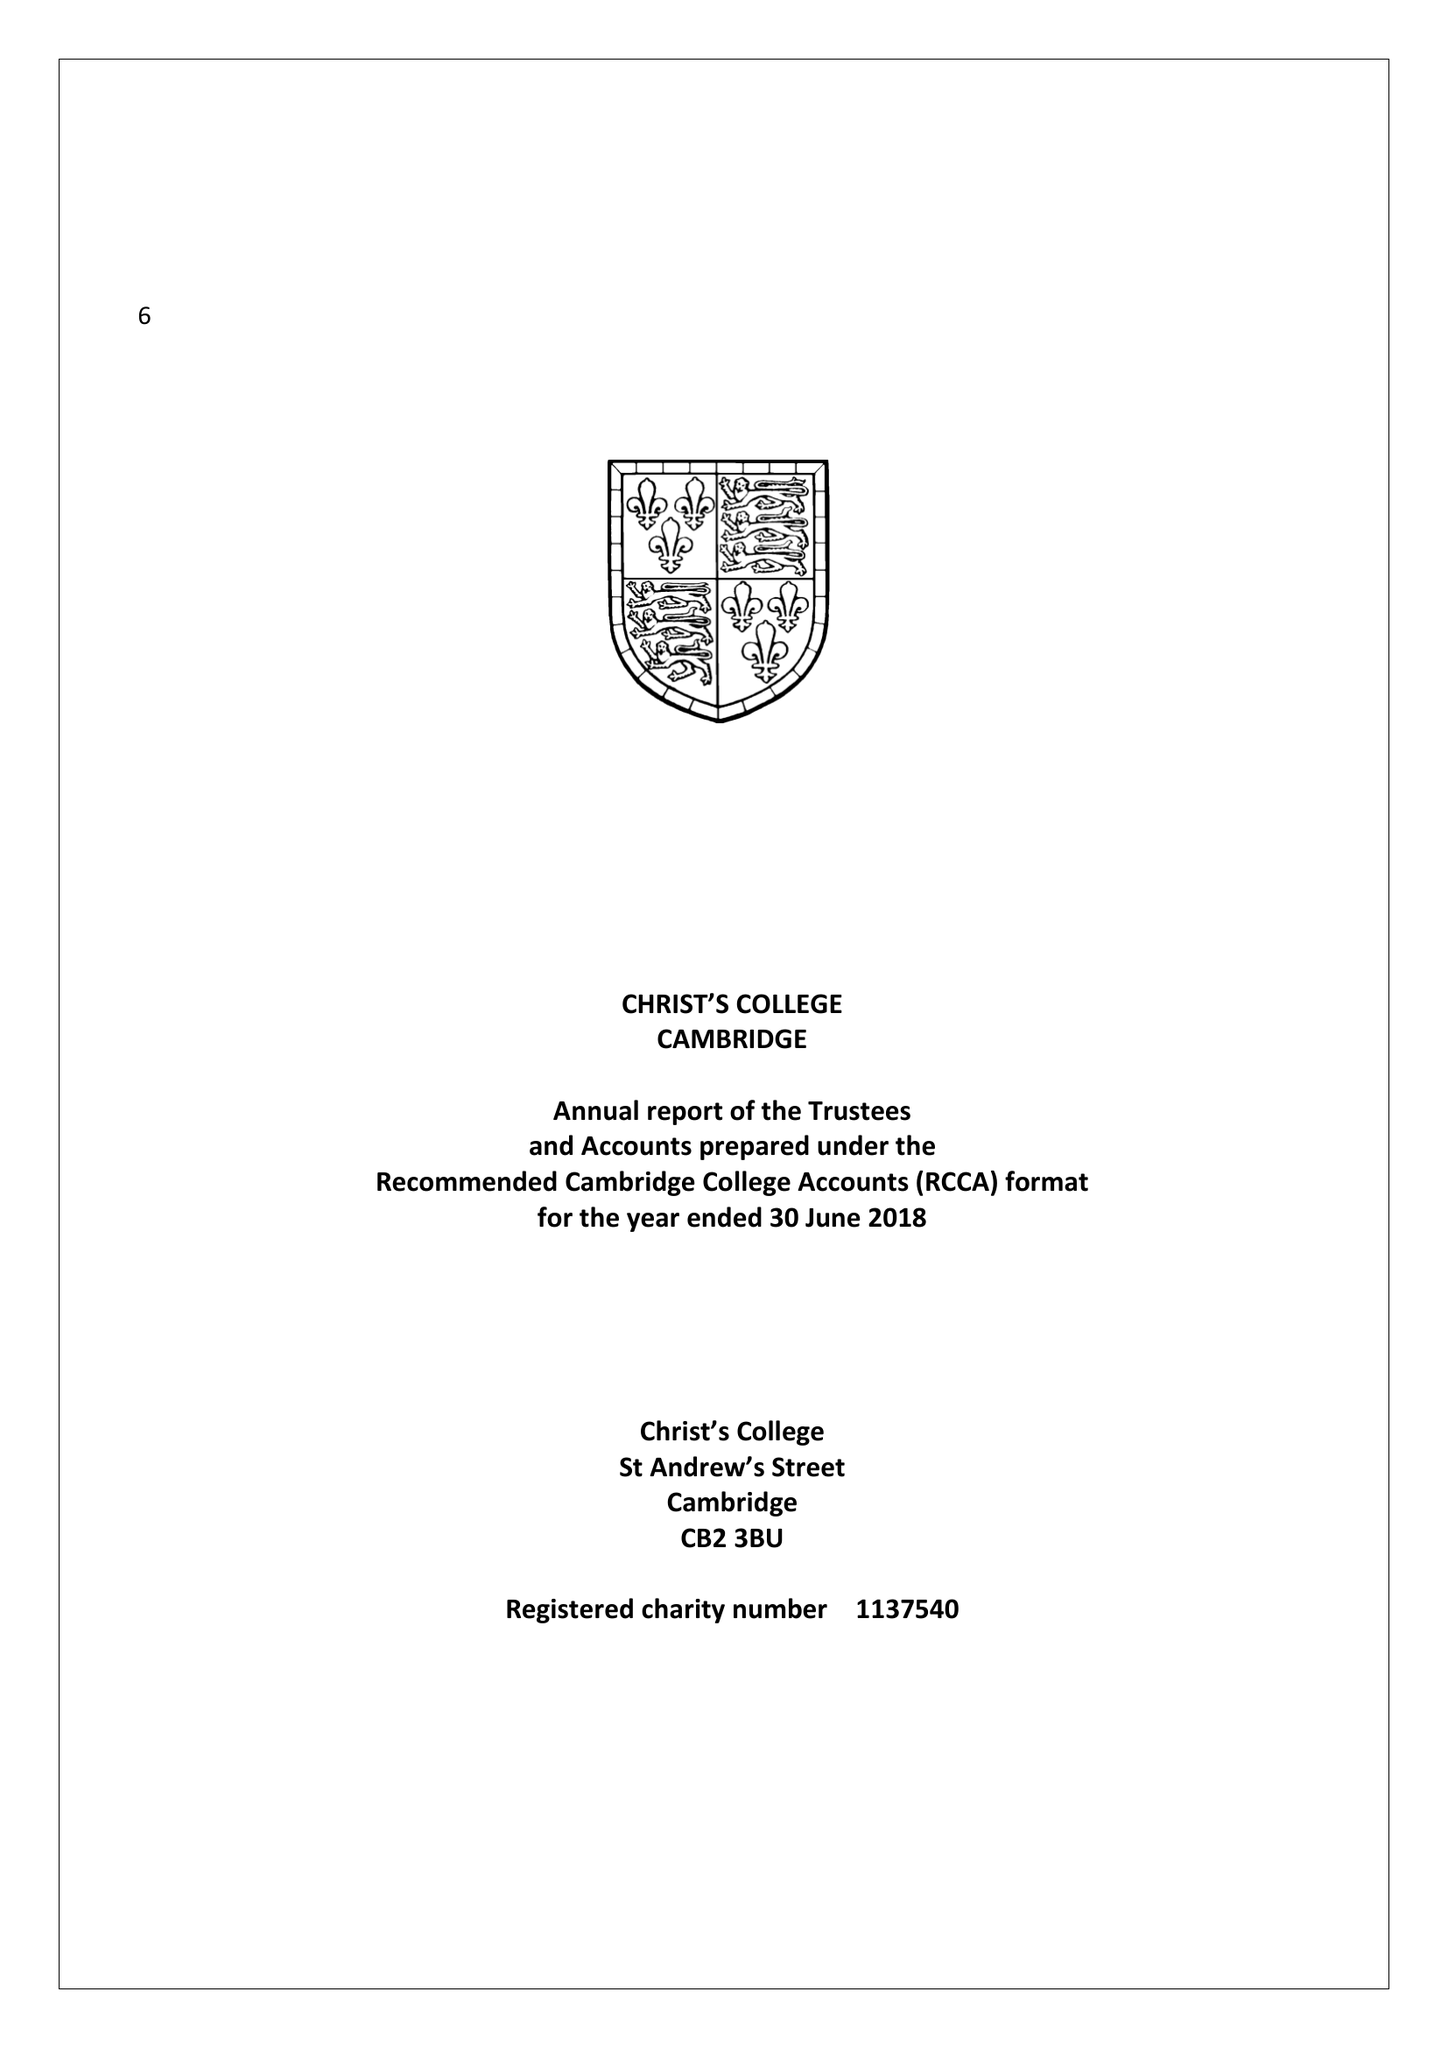What is the value for the spending_annually_in_british_pounds?
Answer the question using a single word or phrase. 11011840.00 